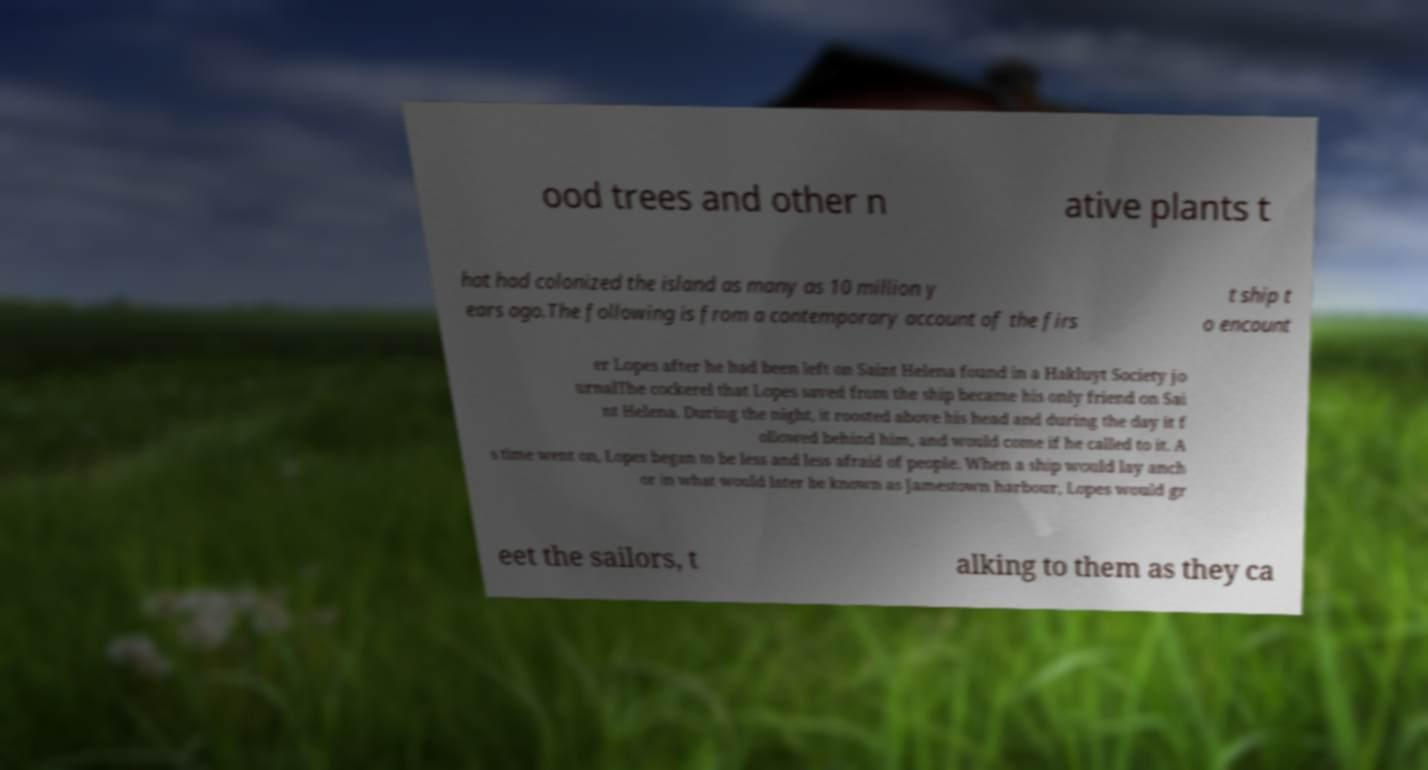Please read and relay the text visible in this image. What does it say? ood trees and other n ative plants t hat had colonized the island as many as 10 million y ears ago.The following is from a contemporary account of the firs t ship t o encount er Lopes after he had been left on Saint Helena found in a Hakluyt Society jo urnalThe cockerel that Lopes saved from the ship became his only friend on Sai nt Helena. During the night, it roosted above his head and during the day it f ollowed behind him, and would come if he called to it. A s time went on, Lopes began to be less and less afraid of people. When a ship would lay anch or in what would later be known as Jamestown harbour, Lopes would gr eet the sailors, t alking to them as they ca 